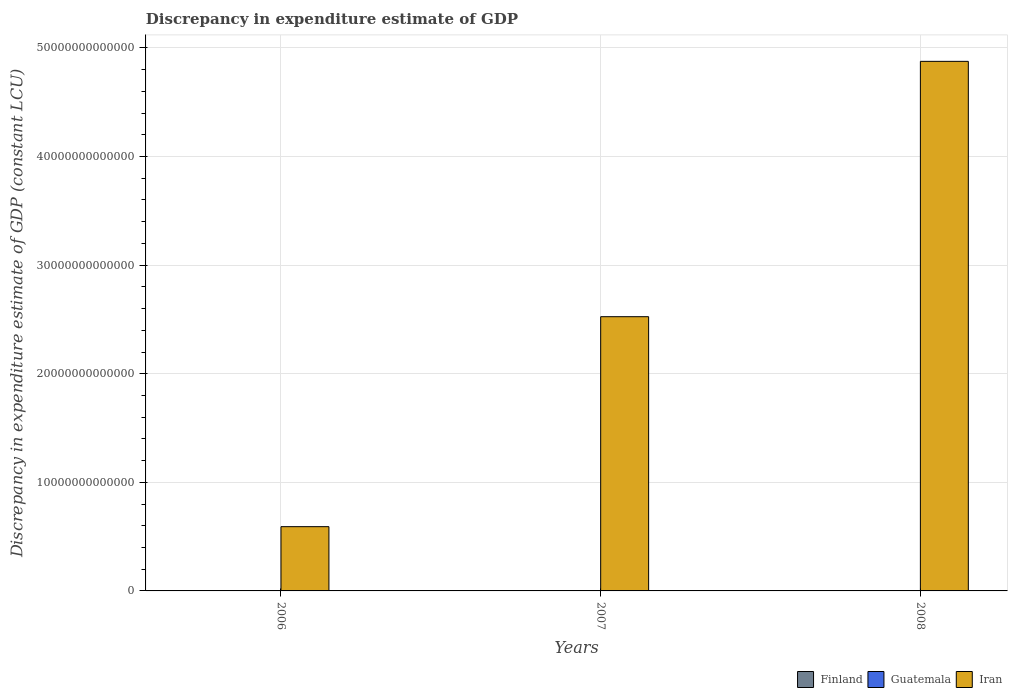How many groups of bars are there?
Offer a terse response. 3. How many bars are there on the 2nd tick from the left?
Offer a very short reply. 2. In how many cases, is the number of bars for a given year not equal to the number of legend labels?
Ensure brevity in your answer.  1. What is the discrepancy in expenditure estimate of GDP in Finland in 2007?
Your answer should be very brief. 9.35e+08. Across all years, what is the maximum discrepancy in expenditure estimate of GDP in Finland?
Offer a terse response. 1.16e+09. Across all years, what is the minimum discrepancy in expenditure estimate of GDP in Iran?
Provide a succinct answer. 5.92e+12. In which year was the discrepancy in expenditure estimate of GDP in Finland maximum?
Keep it short and to the point. 2006. What is the total discrepancy in expenditure estimate of GDP in Iran in the graph?
Your answer should be compact. 7.99e+13. What is the difference between the discrepancy in expenditure estimate of GDP in Iran in 2006 and that in 2007?
Your response must be concise. -1.93e+13. What is the difference between the discrepancy in expenditure estimate of GDP in Guatemala in 2007 and the discrepancy in expenditure estimate of GDP in Iran in 2006?
Keep it short and to the point. -5.92e+12. What is the average discrepancy in expenditure estimate of GDP in Guatemala per year?
Offer a very short reply. 2.44e+08. In the year 2006, what is the difference between the discrepancy in expenditure estimate of GDP in Finland and discrepancy in expenditure estimate of GDP in Guatemala?
Provide a short and direct response. 1.04e+09. In how many years, is the discrepancy in expenditure estimate of GDP in Guatemala greater than 14000000000000 LCU?
Your answer should be very brief. 0. What is the ratio of the discrepancy in expenditure estimate of GDP in Finland in 2006 to that in 2007?
Make the answer very short. 1.24. Is the discrepancy in expenditure estimate of GDP in Finland in 2007 less than that in 2008?
Offer a very short reply. Yes. What is the difference between the highest and the second highest discrepancy in expenditure estimate of GDP in Iran?
Keep it short and to the point. 2.35e+13. What is the difference between the highest and the lowest discrepancy in expenditure estimate of GDP in Finland?
Offer a very short reply. 2.21e+08. Is the sum of the discrepancy in expenditure estimate of GDP in Finland in 2006 and 2007 greater than the maximum discrepancy in expenditure estimate of GDP in Guatemala across all years?
Provide a short and direct response. Yes. Is it the case that in every year, the sum of the discrepancy in expenditure estimate of GDP in Iran and discrepancy in expenditure estimate of GDP in Finland is greater than the discrepancy in expenditure estimate of GDP in Guatemala?
Your answer should be compact. Yes. What is the difference between two consecutive major ticks on the Y-axis?
Your answer should be very brief. 1.00e+13. Does the graph contain any zero values?
Provide a succinct answer. Yes. How are the legend labels stacked?
Keep it short and to the point. Horizontal. What is the title of the graph?
Provide a succinct answer. Discrepancy in expenditure estimate of GDP. What is the label or title of the X-axis?
Make the answer very short. Years. What is the label or title of the Y-axis?
Your answer should be very brief. Discrepancy in expenditure estimate of GDP (constant LCU). What is the Discrepancy in expenditure estimate of GDP (constant LCU) of Finland in 2006?
Keep it short and to the point. 1.16e+09. What is the Discrepancy in expenditure estimate of GDP (constant LCU) of Guatemala in 2006?
Provide a succinct answer. 1.20e+08. What is the Discrepancy in expenditure estimate of GDP (constant LCU) in Iran in 2006?
Give a very brief answer. 5.92e+12. What is the Discrepancy in expenditure estimate of GDP (constant LCU) in Finland in 2007?
Keep it short and to the point. 9.35e+08. What is the Discrepancy in expenditure estimate of GDP (constant LCU) of Guatemala in 2007?
Make the answer very short. 0. What is the Discrepancy in expenditure estimate of GDP (constant LCU) in Iran in 2007?
Provide a succinct answer. 2.53e+13. What is the Discrepancy in expenditure estimate of GDP (constant LCU) in Finland in 2008?
Make the answer very short. 9.97e+08. What is the Discrepancy in expenditure estimate of GDP (constant LCU) of Guatemala in 2008?
Provide a short and direct response. 6.12e+08. What is the Discrepancy in expenditure estimate of GDP (constant LCU) of Iran in 2008?
Offer a very short reply. 4.88e+13. Across all years, what is the maximum Discrepancy in expenditure estimate of GDP (constant LCU) in Finland?
Offer a terse response. 1.16e+09. Across all years, what is the maximum Discrepancy in expenditure estimate of GDP (constant LCU) in Guatemala?
Provide a succinct answer. 6.12e+08. Across all years, what is the maximum Discrepancy in expenditure estimate of GDP (constant LCU) in Iran?
Your answer should be very brief. 4.88e+13. Across all years, what is the minimum Discrepancy in expenditure estimate of GDP (constant LCU) in Finland?
Provide a short and direct response. 9.35e+08. Across all years, what is the minimum Discrepancy in expenditure estimate of GDP (constant LCU) of Guatemala?
Keep it short and to the point. 0. Across all years, what is the minimum Discrepancy in expenditure estimate of GDP (constant LCU) in Iran?
Provide a short and direct response. 5.92e+12. What is the total Discrepancy in expenditure estimate of GDP (constant LCU) in Finland in the graph?
Provide a succinct answer. 3.09e+09. What is the total Discrepancy in expenditure estimate of GDP (constant LCU) in Guatemala in the graph?
Your response must be concise. 7.32e+08. What is the total Discrepancy in expenditure estimate of GDP (constant LCU) of Iran in the graph?
Provide a short and direct response. 7.99e+13. What is the difference between the Discrepancy in expenditure estimate of GDP (constant LCU) in Finland in 2006 and that in 2007?
Offer a terse response. 2.21e+08. What is the difference between the Discrepancy in expenditure estimate of GDP (constant LCU) in Iran in 2006 and that in 2007?
Provide a short and direct response. -1.93e+13. What is the difference between the Discrepancy in expenditure estimate of GDP (constant LCU) of Finland in 2006 and that in 2008?
Offer a very short reply. 1.59e+08. What is the difference between the Discrepancy in expenditure estimate of GDP (constant LCU) in Guatemala in 2006 and that in 2008?
Offer a terse response. -4.92e+08. What is the difference between the Discrepancy in expenditure estimate of GDP (constant LCU) of Iran in 2006 and that in 2008?
Your answer should be compact. -4.29e+13. What is the difference between the Discrepancy in expenditure estimate of GDP (constant LCU) of Finland in 2007 and that in 2008?
Keep it short and to the point. -6.20e+07. What is the difference between the Discrepancy in expenditure estimate of GDP (constant LCU) of Iran in 2007 and that in 2008?
Offer a terse response. -2.35e+13. What is the difference between the Discrepancy in expenditure estimate of GDP (constant LCU) of Finland in 2006 and the Discrepancy in expenditure estimate of GDP (constant LCU) of Iran in 2007?
Your response must be concise. -2.53e+13. What is the difference between the Discrepancy in expenditure estimate of GDP (constant LCU) of Guatemala in 2006 and the Discrepancy in expenditure estimate of GDP (constant LCU) of Iran in 2007?
Make the answer very short. -2.53e+13. What is the difference between the Discrepancy in expenditure estimate of GDP (constant LCU) in Finland in 2006 and the Discrepancy in expenditure estimate of GDP (constant LCU) in Guatemala in 2008?
Ensure brevity in your answer.  5.44e+08. What is the difference between the Discrepancy in expenditure estimate of GDP (constant LCU) in Finland in 2006 and the Discrepancy in expenditure estimate of GDP (constant LCU) in Iran in 2008?
Your answer should be compact. -4.88e+13. What is the difference between the Discrepancy in expenditure estimate of GDP (constant LCU) of Guatemala in 2006 and the Discrepancy in expenditure estimate of GDP (constant LCU) of Iran in 2008?
Your answer should be compact. -4.88e+13. What is the difference between the Discrepancy in expenditure estimate of GDP (constant LCU) in Finland in 2007 and the Discrepancy in expenditure estimate of GDP (constant LCU) in Guatemala in 2008?
Offer a very short reply. 3.23e+08. What is the difference between the Discrepancy in expenditure estimate of GDP (constant LCU) of Finland in 2007 and the Discrepancy in expenditure estimate of GDP (constant LCU) of Iran in 2008?
Ensure brevity in your answer.  -4.88e+13. What is the average Discrepancy in expenditure estimate of GDP (constant LCU) in Finland per year?
Ensure brevity in your answer.  1.03e+09. What is the average Discrepancy in expenditure estimate of GDP (constant LCU) in Guatemala per year?
Your response must be concise. 2.44e+08. What is the average Discrepancy in expenditure estimate of GDP (constant LCU) of Iran per year?
Ensure brevity in your answer.  2.66e+13. In the year 2006, what is the difference between the Discrepancy in expenditure estimate of GDP (constant LCU) of Finland and Discrepancy in expenditure estimate of GDP (constant LCU) of Guatemala?
Make the answer very short. 1.04e+09. In the year 2006, what is the difference between the Discrepancy in expenditure estimate of GDP (constant LCU) of Finland and Discrepancy in expenditure estimate of GDP (constant LCU) of Iran?
Provide a succinct answer. -5.92e+12. In the year 2006, what is the difference between the Discrepancy in expenditure estimate of GDP (constant LCU) in Guatemala and Discrepancy in expenditure estimate of GDP (constant LCU) in Iran?
Keep it short and to the point. -5.92e+12. In the year 2007, what is the difference between the Discrepancy in expenditure estimate of GDP (constant LCU) in Finland and Discrepancy in expenditure estimate of GDP (constant LCU) in Iran?
Keep it short and to the point. -2.53e+13. In the year 2008, what is the difference between the Discrepancy in expenditure estimate of GDP (constant LCU) of Finland and Discrepancy in expenditure estimate of GDP (constant LCU) of Guatemala?
Keep it short and to the point. 3.85e+08. In the year 2008, what is the difference between the Discrepancy in expenditure estimate of GDP (constant LCU) in Finland and Discrepancy in expenditure estimate of GDP (constant LCU) in Iran?
Your answer should be very brief. -4.88e+13. In the year 2008, what is the difference between the Discrepancy in expenditure estimate of GDP (constant LCU) in Guatemala and Discrepancy in expenditure estimate of GDP (constant LCU) in Iran?
Your answer should be compact. -4.88e+13. What is the ratio of the Discrepancy in expenditure estimate of GDP (constant LCU) of Finland in 2006 to that in 2007?
Make the answer very short. 1.24. What is the ratio of the Discrepancy in expenditure estimate of GDP (constant LCU) in Iran in 2006 to that in 2007?
Keep it short and to the point. 0.23. What is the ratio of the Discrepancy in expenditure estimate of GDP (constant LCU) of Finland in 2006 to that in 2008?
Offer a terse response. 1.16. What is the ratio of the Discrepancy in expenditure estimate of GDP (constant LCU) in Guatemala in 2006 to that in 2008?
Provide a succinct answer. 0.2. What is the ratio of the Discrepancy in expenditure estimate of GDP (constant LCU) in Iran in 2006 to that in 2008?
Ensure brevity in your answer.  0.12. What is the ratio of the Discrepancy in expenditure estimate of GDP (constant LCU) in Finland in 2007 to that in 2008?
Ensure brevity in your answer.  0.94. What is the ratio of the Discrepancy in expenditure estimate of GDP (constant LCU) in Iran in 2007 to that in 2008?
Your answer should be very brief. 0.52. What is the difference between the highest and the second highest Discrepancy in expenditure estimate of GDP (constant LCU) of Finland?
Offer a terse response. 1.59e+08. What is the difference between the highest and the second highest Discrepancy in expenditure estimate of GDP (constant LCU) in Iran?
Your response must be concise. 2.35e+13. What is the difference between the highest and the lowest Discrepancy in expenditure estimate of GDP (constant LCU) in Finland?
Your answer should be compact. 2.21e+08. What is the difference between the highest and the lowest Discrepancy in expenditure estimate of GDP (constant LCU) in Guatemala?
Keep it short and to the point. 6.12e+08. What is the difference between the highest and the lowest Discrepancy in expenditure estimate of GDP (constant LCU) in Iran?
Make the answer very short. 4.29e+13. 